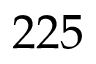Convert formula to latex. <formula><loc_0><loc_0><loc_500><loc_500>2 2 5</formula> 